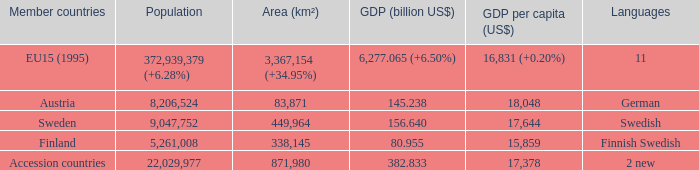Name the population for 11 languages 372,939,379 (+6.28%). 